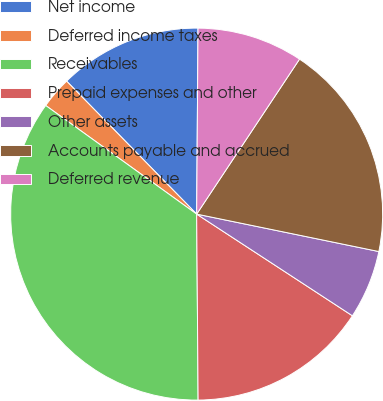Convert chart. <chart><loc_0><loc_0><loc_500><loc_500><pie_chart><fcel>Net income<fcel>Deferred income taxes<fcel>Receivables<fcel>Prepaid expenses and other<fcel>Other assets<fcel>Accounts payable and accrued<fcel>Deferred revenue<nl><fcel>12.44%<fcel>2.75%<fcel>35.05%<fcel>15.67%<fcel>5.98%<fcel>18.9%<fcel>9.21%<nl></chart> 